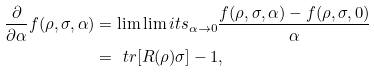<formula> <loc_0><loc_0><loc_500><loc_500>\frac { \partial } { \partial \alpha } f ( \rho , \sigma , \alpha ) & = \lim \lim i t s _ { \alpha \rightarrow 0 } \frac { f ( \rho , \sigma , \alpha ) - f ( \rho , \sigma , 0 ) } { \alpha } \\ & = \ t r [ R ( \rho ) \sigma ] - 1 ,</formula> 